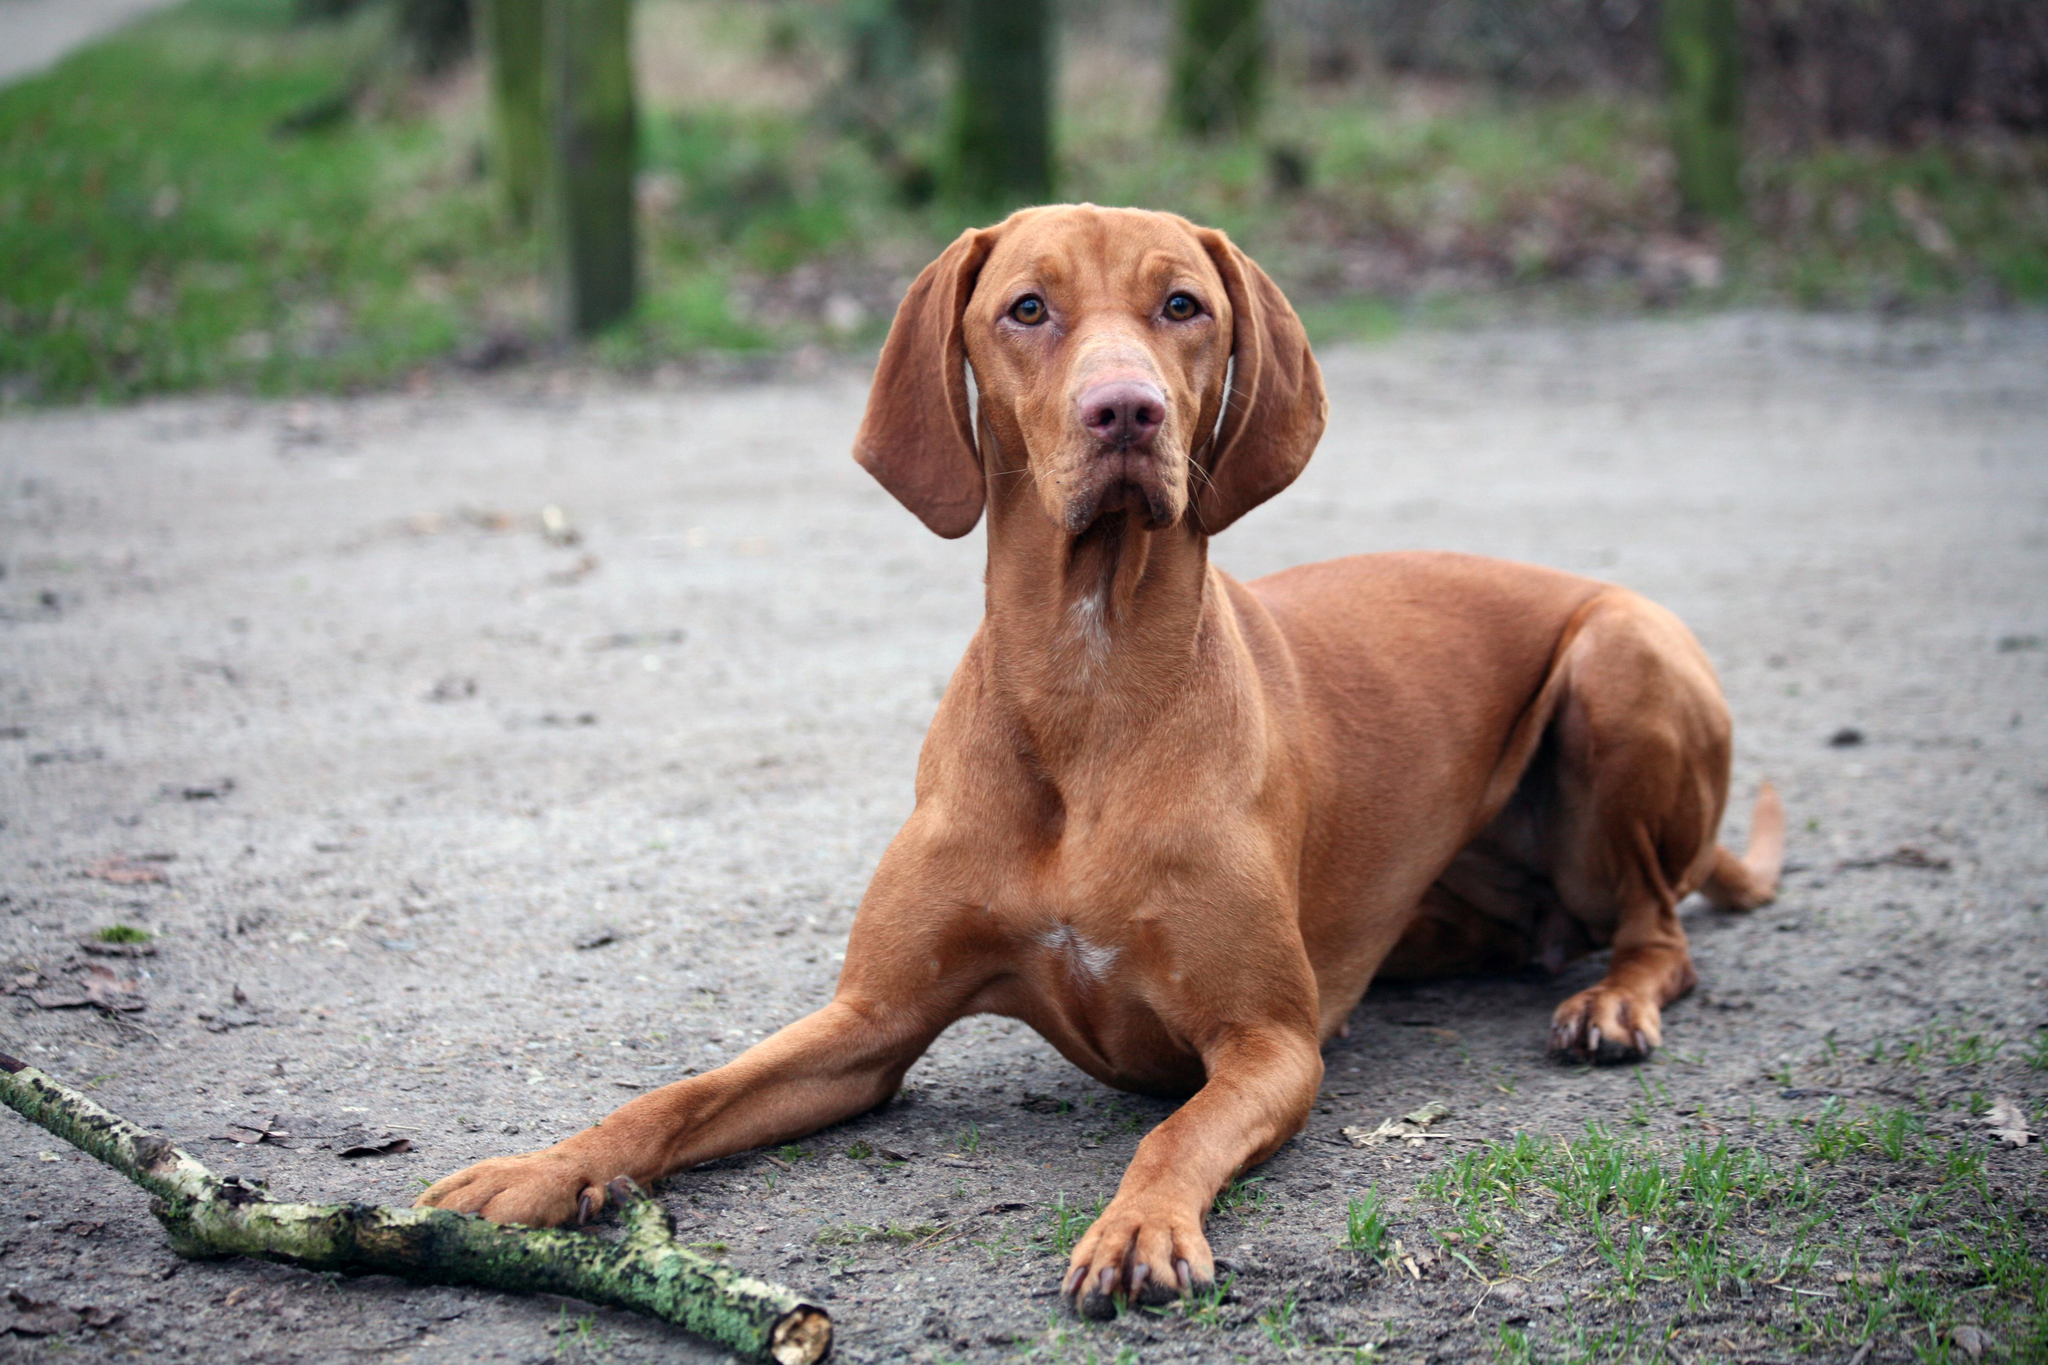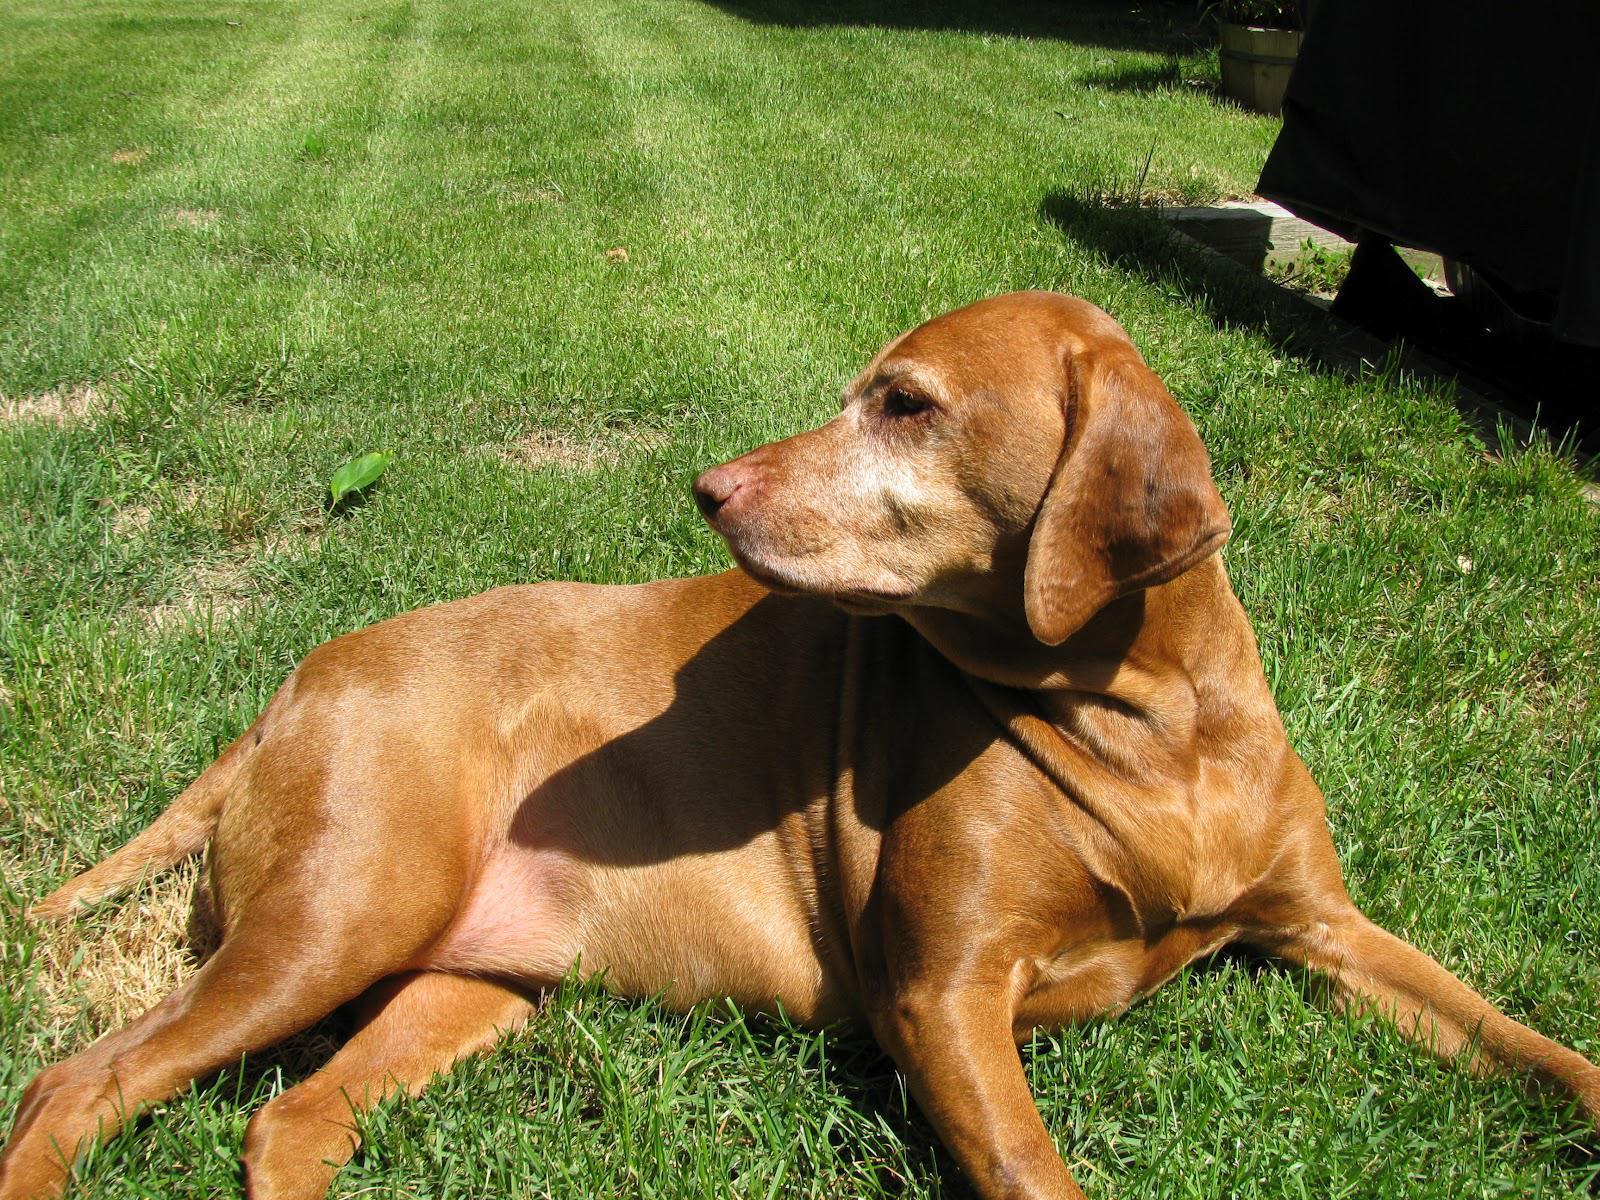The first image is the image on the left, the second image is the image on the right. Considering the images on both sides, is "There is a dog wearing a red collar in each image." valid? Answer yes or no. No. The first image is the image on the left, the second image is the image on the right. For the images displayed, is the sentence "There is the same number of dogs in both images." factually correct? Answer yes or no. Yes. 